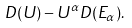<formula> <loc_0><loc_0><loc_500><loc_500>D ( { U } ) - U ^ { \alpha } D ( { E } _ { \alpha } ) .</formula> 